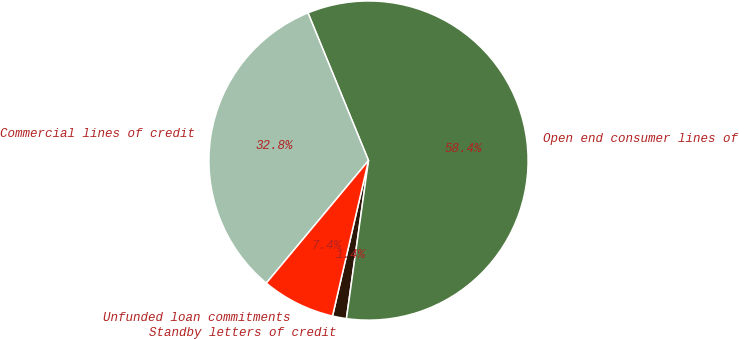<chart> <loc_0><loc_0><loc_500><loc_500><pie_chart><fcel>Standby letters of credit<fcel>Open end consumer lines of<fcel>Commercial lines of credit<fcel>Unfunded loan commitments<nl><fcel>1.41%<fcel>58.4%<fcel>32.75%<fcel>7.44%<nl></chart> 